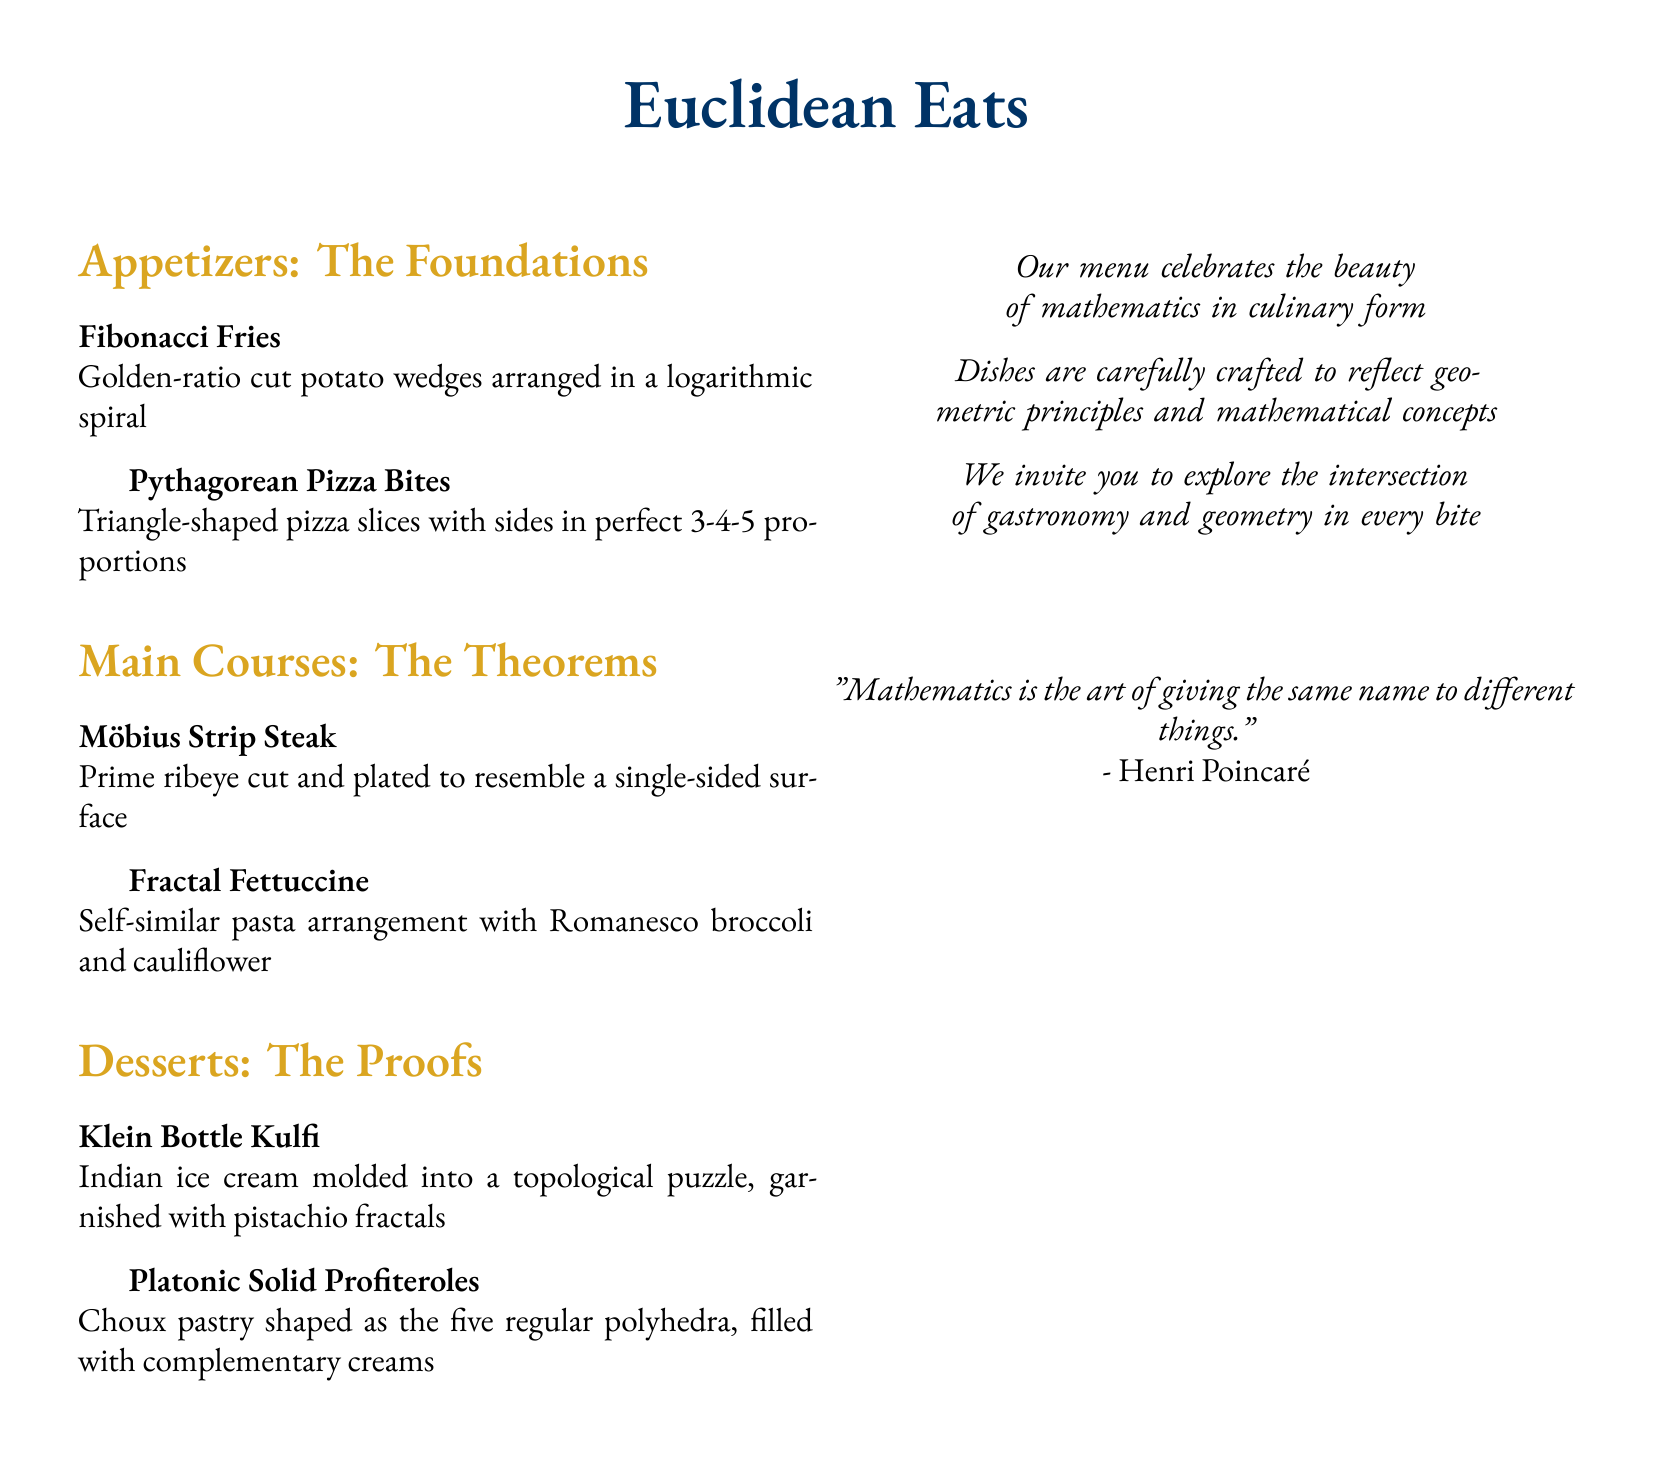What is the name of the restaurant? The name of the restaurant is prominently featured at the top of the menu.
Answer: Euclidean Eats How many sections are there in the menu? The menu consists of three distinct sections for different types of dishes.
Answer: Three What type of dish is "Möbius Strip Steak"? The dish is categorized under the "Main Courses" section of the menu.
Answer: Main Course What geometric shape is used in the "Fibonacci Fries"? The dish is arranged in a specific mathematical pattern referenced in its description.
Answer: Logarithmic spiral How many appetizers are listed on the menu? The menu contains two distinct appetizers that serve as the foundation dishes.
Answer: Two What dessert is inspired by a topological puzzle? The dessert's name indicates its inspiration from a complex mathematical structure.
Answer: Klein Bottle Kulfi How are the "Platonic Solid Profiteroles" shaped? The description notes the form of the dessert related to mathematical solids.
Answer: Regular polyhedra What color is used for the section titles? The titles of each section feature a specific color to distinguish them.
Answer: Gold What is the overall theme of the menu? The menu's introduction suggests a strong thematic connection between two disciplines.
Answer: Mathematics and gastronomy 